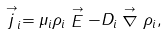Convert formula to latex. <formula><loc_0><loc_0><loc_500><loc_500>\stackrel { \rightarrow } { j } _ { i } = \mu _ { i } \rho _ { i } \stackrel { \rightarrow } { E } - D _ { i } \stackrel { \rightarrow } { \nabla } \rho _ { i } ,</formula> 